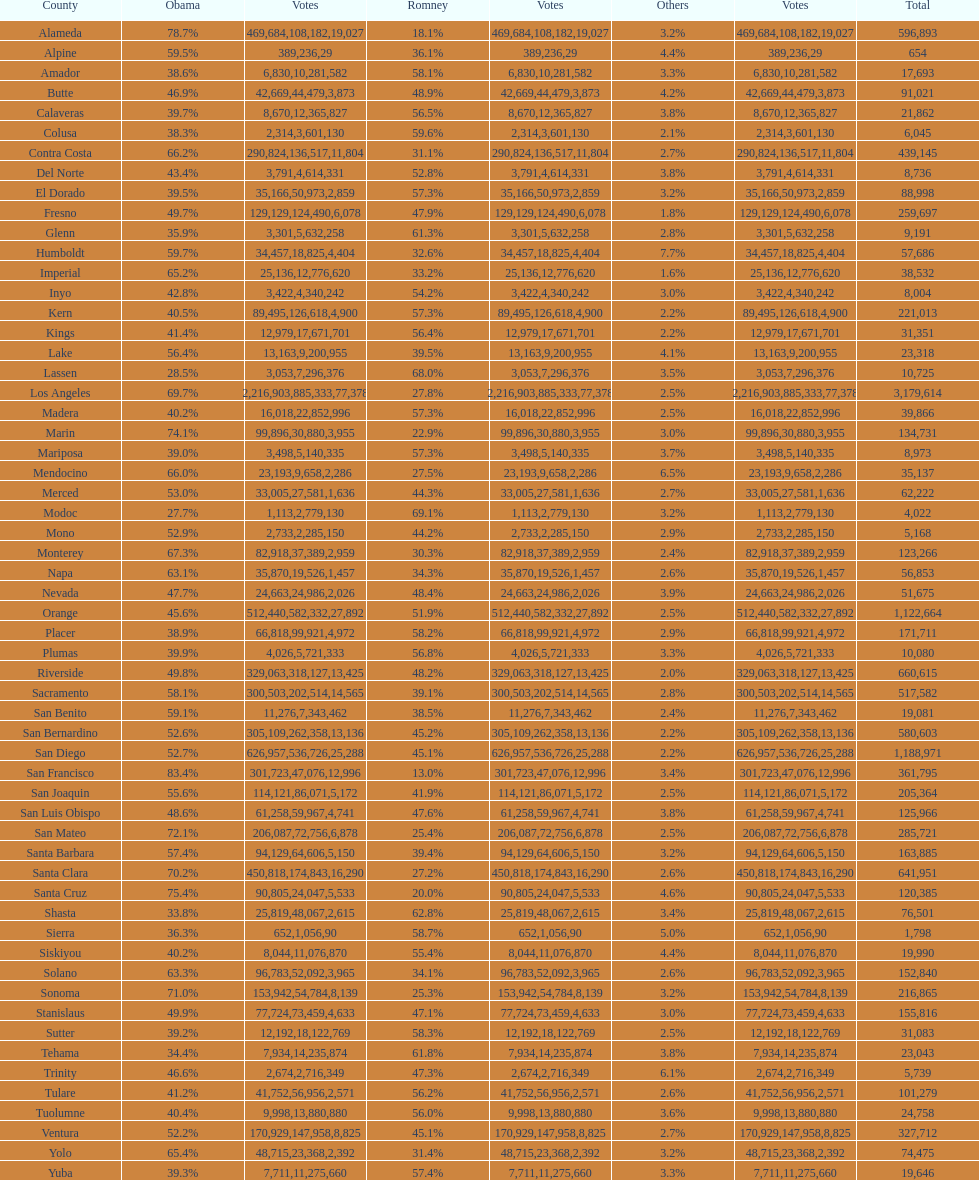How many counties had at least 75% of the votes for obama? 3. 